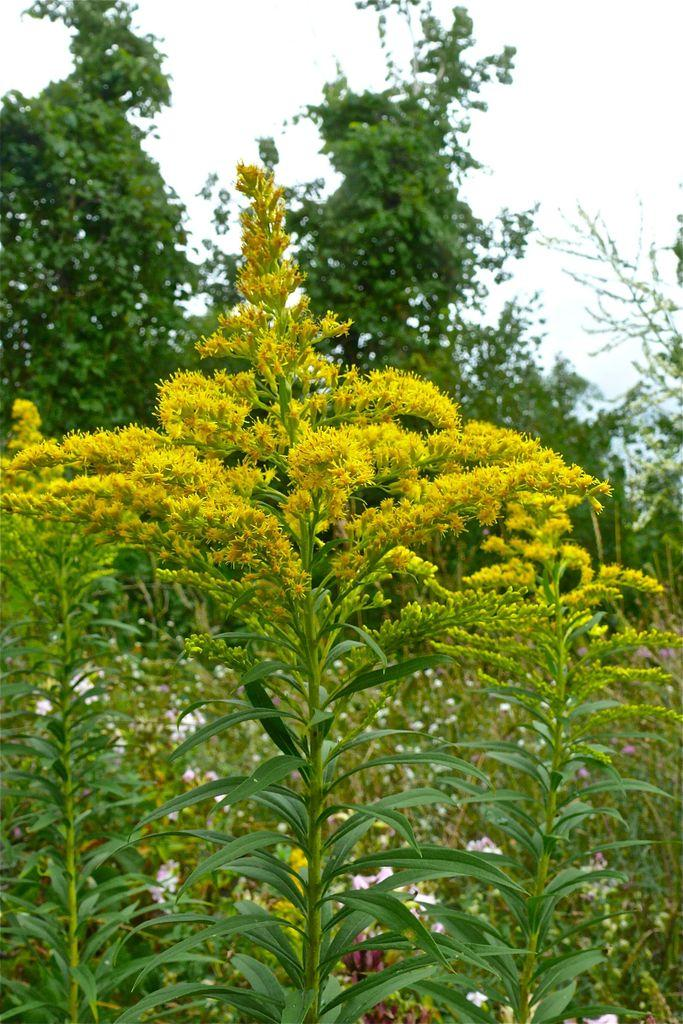What type of vegetation is present in the image? There are many plants in the image. What specific feature can be observed on the plants? The plants have flowers. What can be seen in the background of the image? There are trees in the background of the image. What is visible at the top of the image? The sky is visible at the top of the image. How many yaks are pulling the truck in the image? There is no truck or yaks present in the image. 